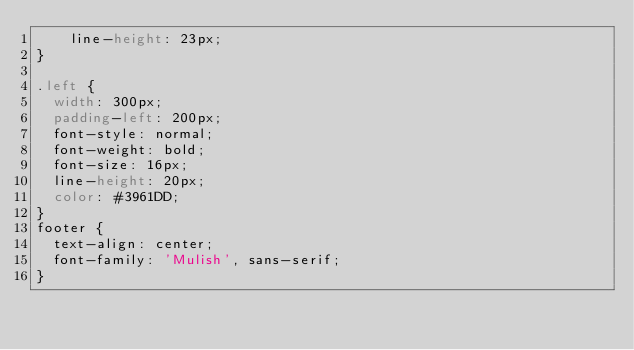Convert code to text. <code><loc_0><loc_0><loc_500><loc_500><_CSS_>    line-height: 23px;
}

.left {
  width: 300px;
  padding-left: 200px;
  font-style: normal;
  font-weight: bold;
  font-size: 16px;
  line-height: 20px;
  color: #3961DD;
}
footer {
  text-align: center;
  font-family: 'Mulish', sans-serif;
}</code> 